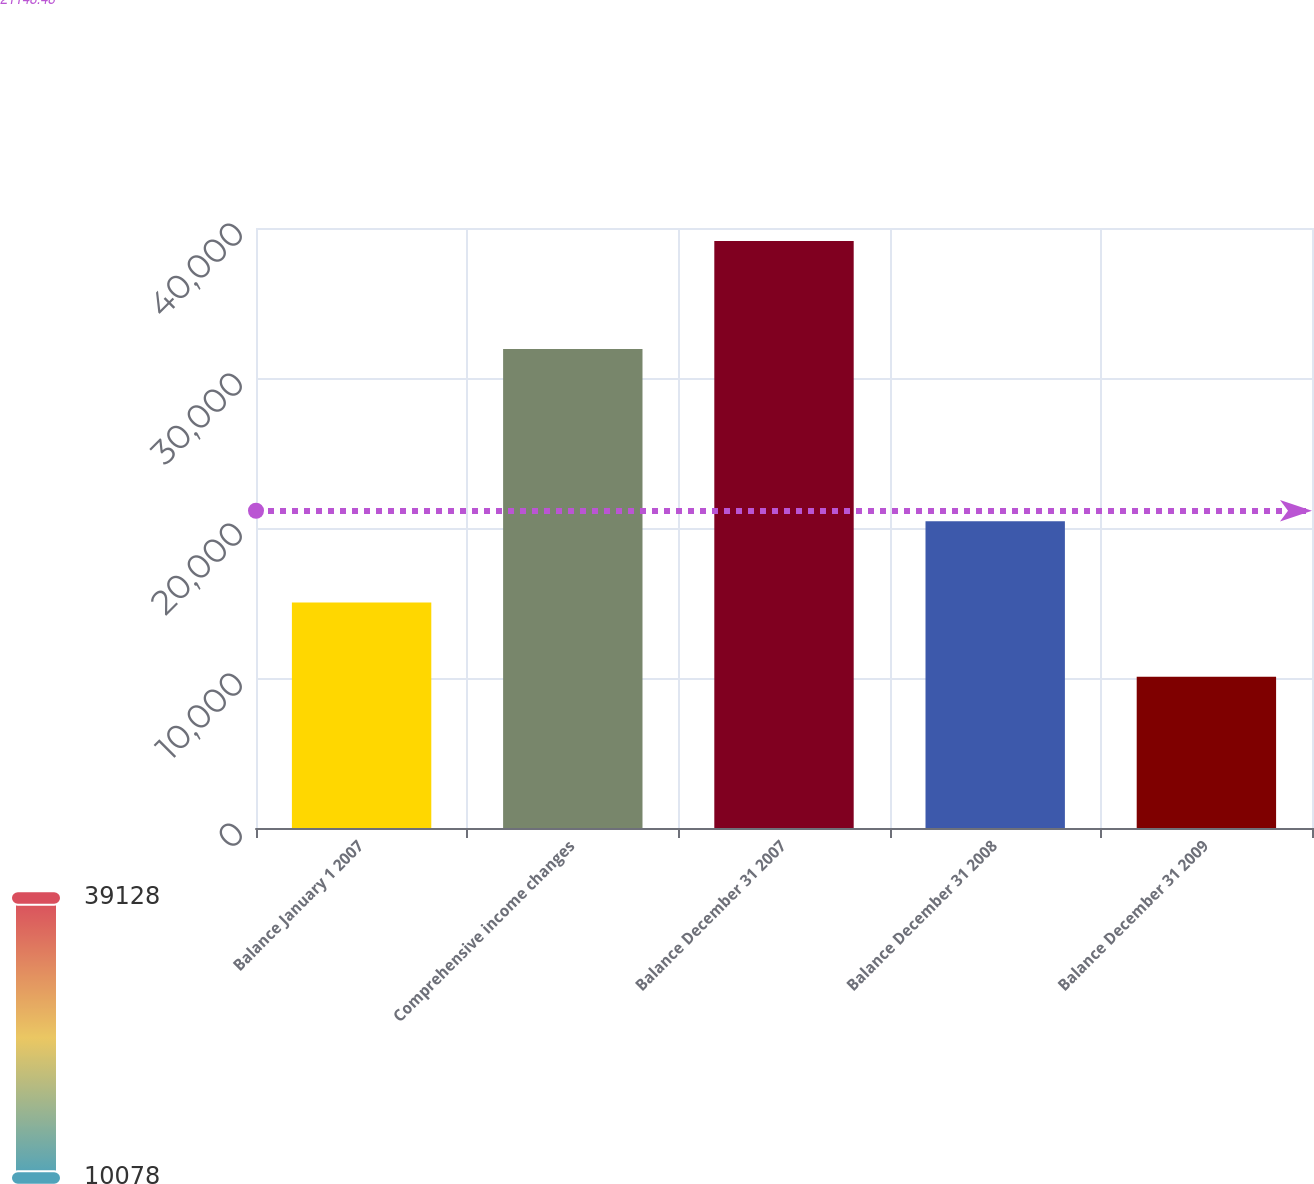<chart> <loc_0><loc_0><loc_500><loc_500><bar_chart><fcel>Balance January 1 2007<fcel>Comprehensive income changes<fcel>Balance December 31 2007<fcel>Balance December 31 2008<fcel>Balance December 31 2009<nl><fcel>15028.4<fcel>31925.4<fcel>39128<fcel>20454<fcel>10078<nl></chart> 